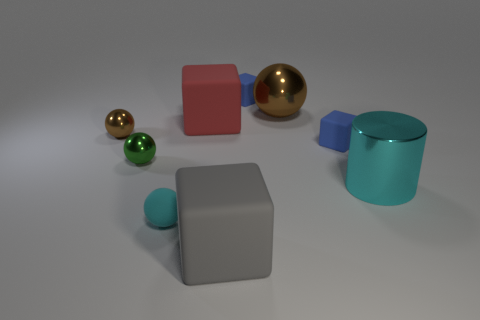Subtract 1 blocks. How many blocks are left? 3 Add 1 cyan cylinders. How many objects exist? 10 Subtract all spheres. How many objects are left? 5 Add 1 cylinders. How many cylinders are left? 2 Add 3 red rubber cylinders. How many red rubber cylinders exist? 3 Subtract 0 gray cylinders. How many objects are left? 9 Subtract all rubber cubes. Subtract all yellow objects. How many objects are left? 5 